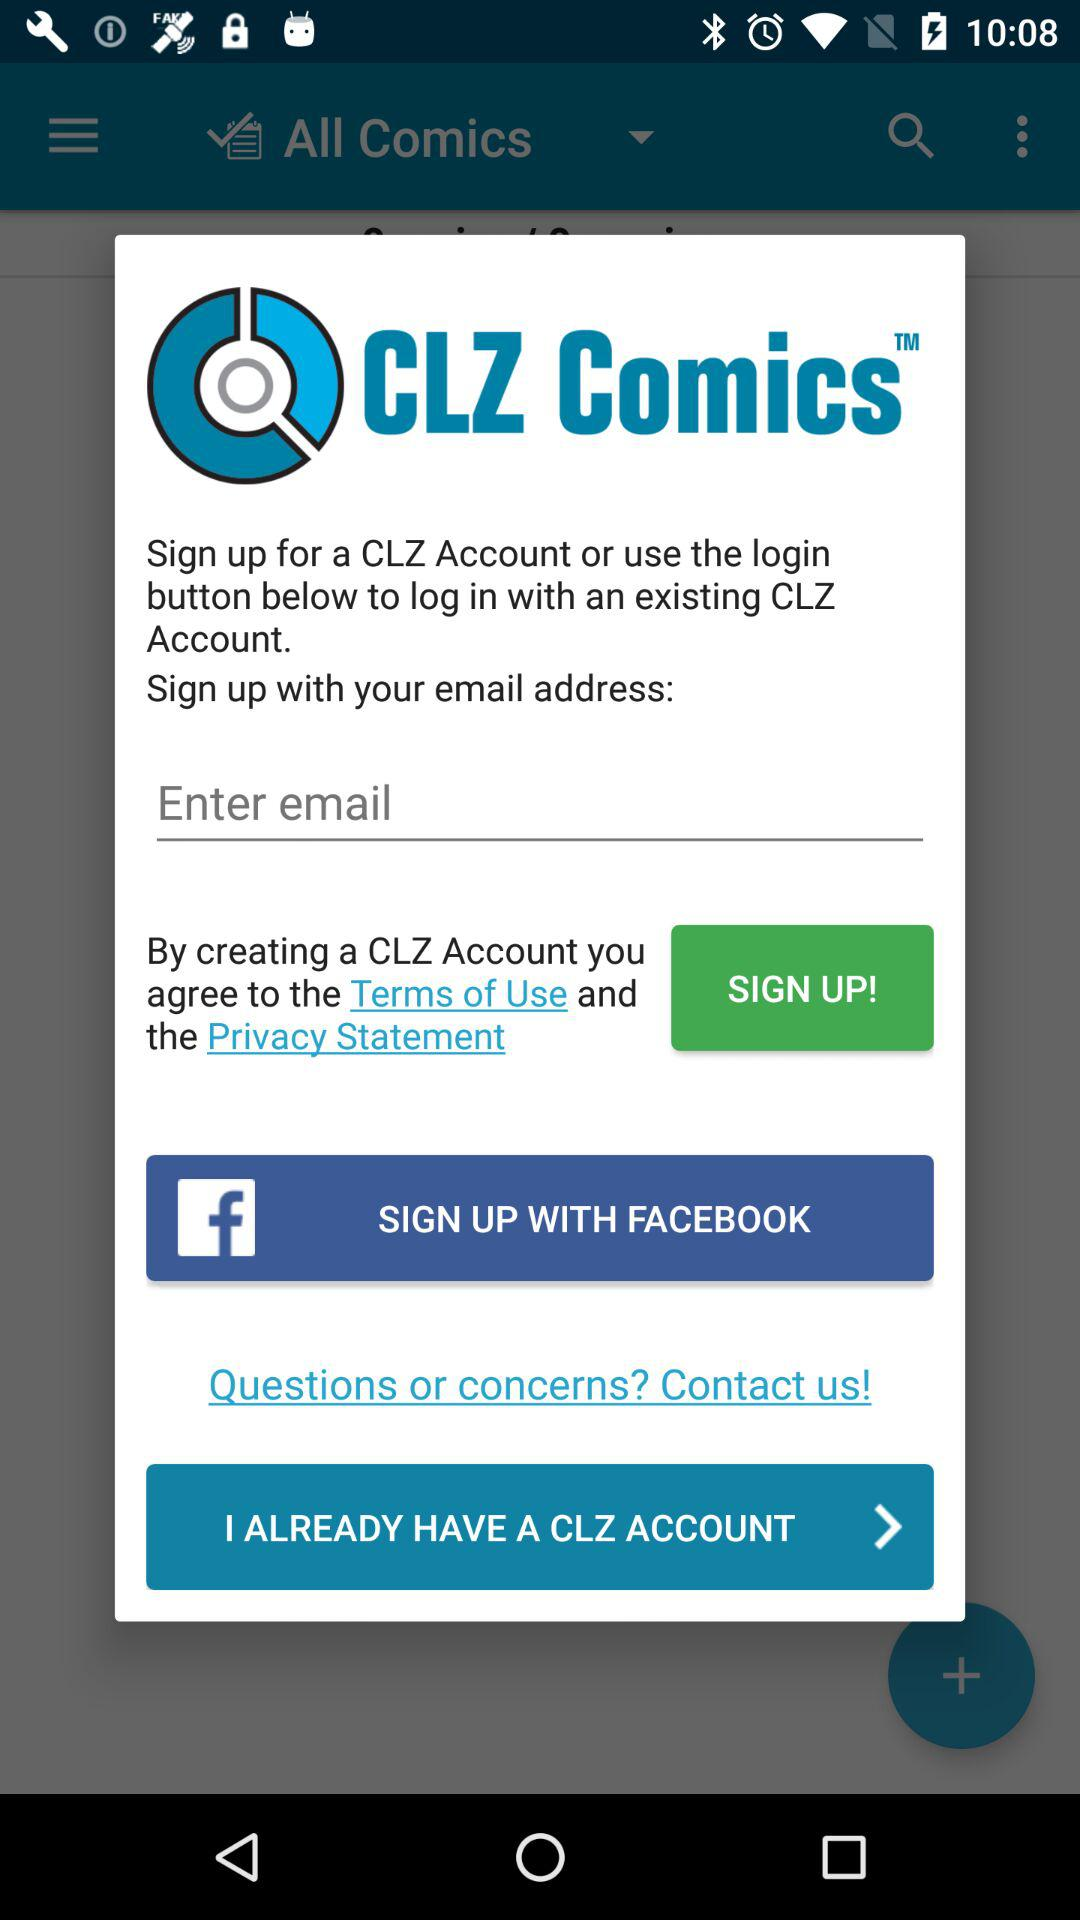What are the different options available for signing up? The different options available for signing up are "email address" and "FACEBOOK". 